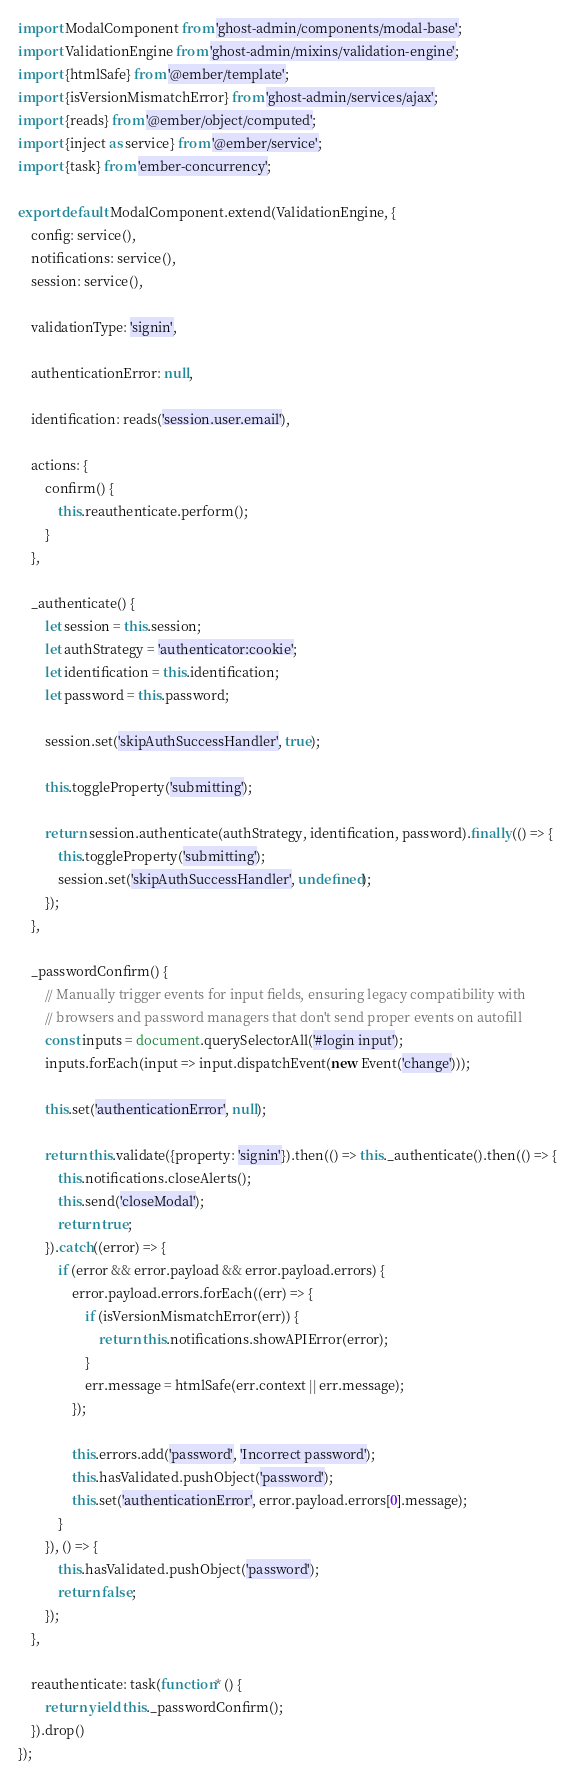Convert code to text. <code><loc_0><loc_0><loc_500><loc_500><_JavaScript_>import ModalComponent from 'ghost-admin/components/modal-base';
import ValidationEngine from 'ghost-admin/mixins/validation-engine';
import {htmlSafe} from '@ember/template';
import {isVersionMismatchError} from 'ghost-admin/services/ajax';
import {reads} from '@ember/object/computed';
import {inject as service} from '@ember/service';
import {task} from 'ember-concurrency';

export default ModalComponent.extend(ValidationEngine, {
    config: service(),
    notifications: service(),
    session: service(),

    validationType: 'signin',

    authenticationError: null,

    identification: reads('session.user.email'),

    actions: {
        confirm() {
            this.reauthenticate.perform();
        }
    },

    _authenticate() {
        let session = this.session;
        let authStrategy = 'authenticator:cookie';
        let identification = this.identification;
        let password = this.password;

        session.set('skipAuthSuccessHandler', true);

        this.toggleProperty('submitting');

        return session.authenticate(authStrategy, identification, password).finally(() => {
            this.toggleProperty('submitting');
            session.set('skipAuthSuccessHandler', undefined);
        });
    },

    _passwordConfirm() {
        // Manually trigger events for input fields, ensuring legacy compatibility with
        // browsers and password managers that don't send proper events on autofill
        const inputs = document.querySelectorAll('#login input');
        inputs.forEach(input => input.dispatchEvent(new Event('change')));

        this.set('authenticationError', null);

        return this.validate({property: 'signin'}).then(() => this._authenticate().then(() => {
            this.notifications.closeAlerts();
            this.send('closeModal');
            return true;
        }).catch((error) => {
            if (error && error.payload && error.payload.errors) {
                error.payload.errors.forEach((err) => {
                    if (isVersionMismatchError(err)) {
                        return this.notifications.showAPIError(error);
                    }
                    err.message = htmlSafe(err.context || err.message);
                });

                this.errors.add('password', 'Incorrect password');
                this.hasValidated.pushObject('password');
                this.set('authenticationError', error.payload.errors[0].message);
            }
        }), () => {
            this.hasValidated.pushObject('password');
            return false;
        });
    },

    reauthenticate: task(function* () {
        return yield this._passwordConfirm();
    }).drop()
});
</code> 